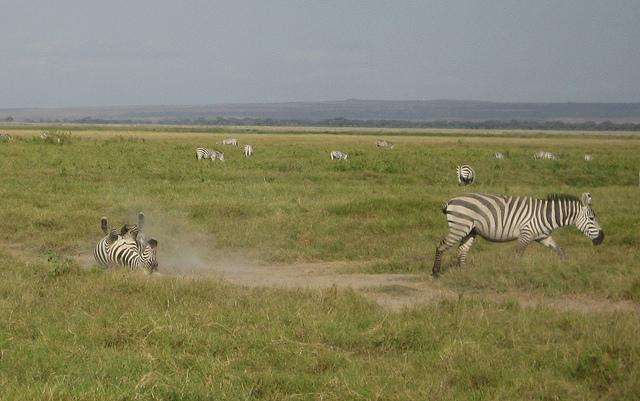What animal is on the ground?
Concise answer only. Zebra. Are the animals in the background zebras?
Be succinct. Yes. How many species are shown?
Answer briefly. 1. Is the zebra on his back because he's playing?
Write a very short answer. No. What is in the far background?
Concise answer only. Mountains. Are these Zebras walking?
Give a very brief answer. Yes. Is the zebra just standing?
Answer briefly. No. Are the zebras walking together or apart?
Write a very short answer. Apart. Does this animal hunt prey?
Answer briefly. No. What is the zebra doing?
Short answer required. Rolling. 